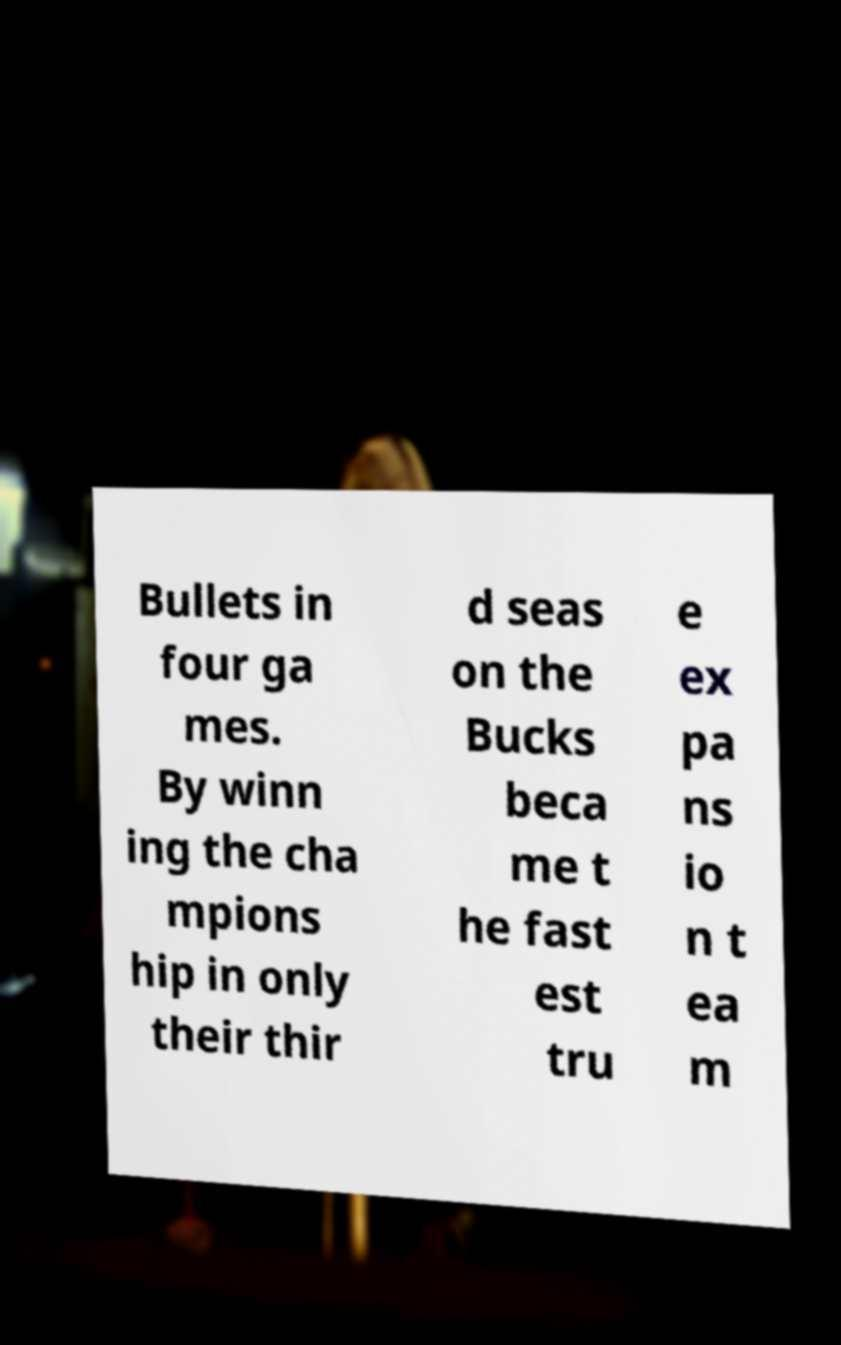I need the written content from this picture converted into text. Can you do that? Bullets in four ga mes. By winn ing the cha mpions hip in only their thir d seas on the Bucks beca me t he fast est tru e ex pa ns io n t ea m 